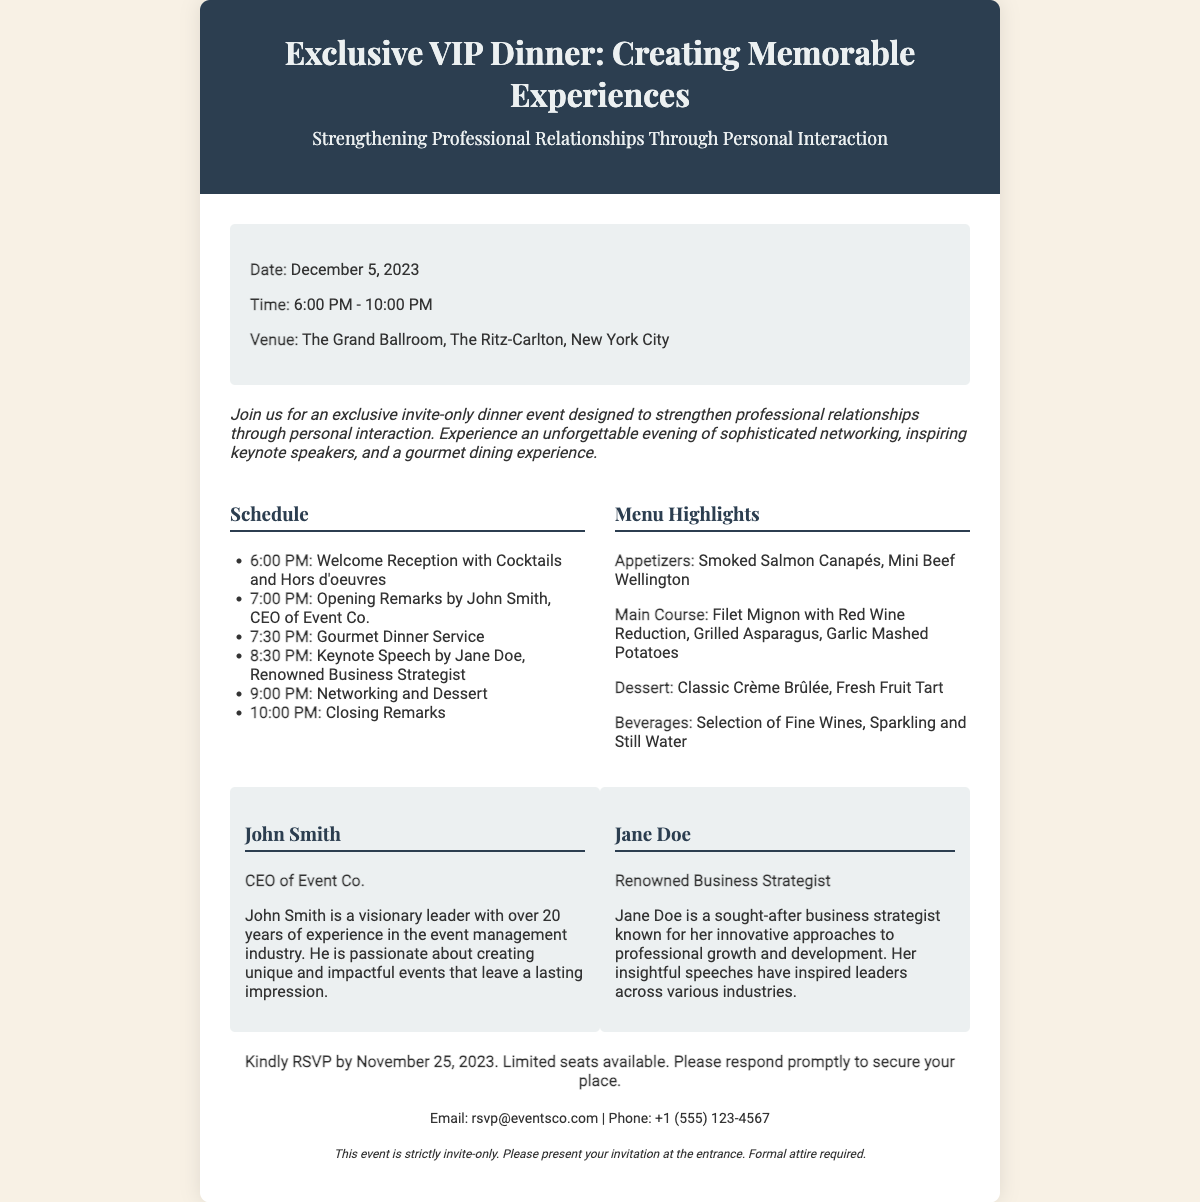What is the date of the event? The date of the event is specified in the document as December 5, 2023.
Answer: December 5, 2023 What is the venue for the dinner? The venue is mentioned in the document as The Grand Ballroom, The Ritz-Carlton, New York City.
Answer: The Grand Ballroom, The Ritz-Carlton, New York City Who is the keynote speaker? The document highlights Jane Doe as the keynote speaker for the event.
Answer: Jane Doe What time does the event start? The event's start time is listed in the document as 6:00 PM.
Answer: 6:00 PM What is the RSVP deadline? The RSVP deadline is mentioned as November 25, 2023.
Answer: November 25, 2023 What is included in the gourmet dinner? The document lists items for the gourmet dinner, including Filet Mignon and Classic Crème Brûlée.
Answer: Filet Mignon with Red Wine Reduction, Classic Crème Brûlée How many speakers are featured in the event? The document presents two speakers featured in the event, John Smith and Jane Doe.
Answer: Two What is the purpose of the event? The document specifies the purpose of the event as strengthening professional relationships through personal interaction.
Answer: Strengthening professional relationships through personal interaction Is formal attire required? The document states that formal attire is required for the event.
Answer: Yes 